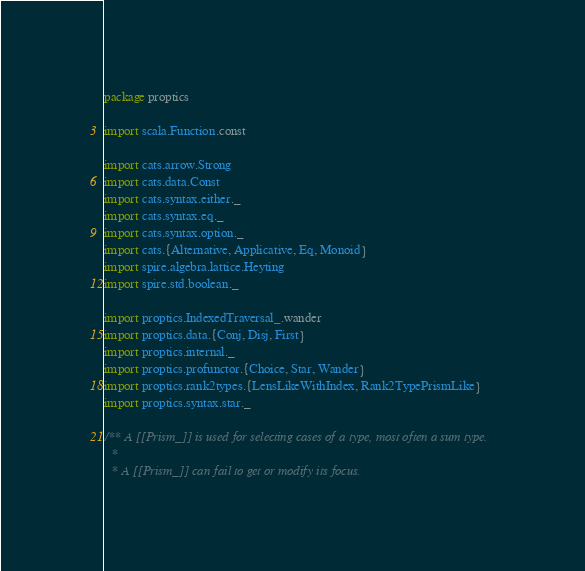<code> <loc_0><loc_0><loc_500><loc_500><_Scala_>package proptics

import scala.Function.const

import cats.arrow.Strong
import cats.data.Const
import cats.syntax.either._
import cats.syntax.eq._
import cats.syntax.option._
import cats.{Alternative, Applicative, Eq, Monoid}
import spire.algebra.lattice.Heyting
import spire.std.boolean._

import proptics.IndexedTraversal_.wander
import proptics.data.{Conj, Disj, First}
import proptics.internal._
import proptics.profunctor.{Choice, Star, Wander}
import proptics.rank2types.{LensLikeWithIndex, Rank2TypePrismLike}
import proptics.syntax.star._

/** A [[Prism_]] is used for selecting cases of a type, most often a sum type.
  *
  * A [[Prism_]] can fail to get or modify its focus.</code> 